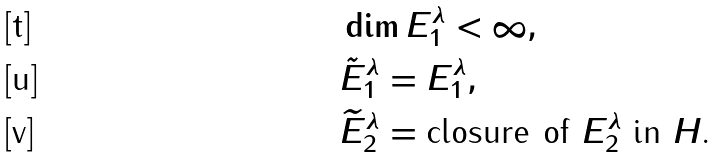Convert formula to latex. <formula><loc_0><loc_0><loc_500><loc_500>& \dim E ^ { \lambda } _ { 1 } < \infty , \\ & \tilde { E } ^ { \lambda } _ { 1 } = E ^ { \lambda } _ { 1 } , \\ & \widetilde { E } ^ { \lambda } _ { 2 } = \text {closure of $E^{\lambda}_{2}$ in $H$.}</formula> 